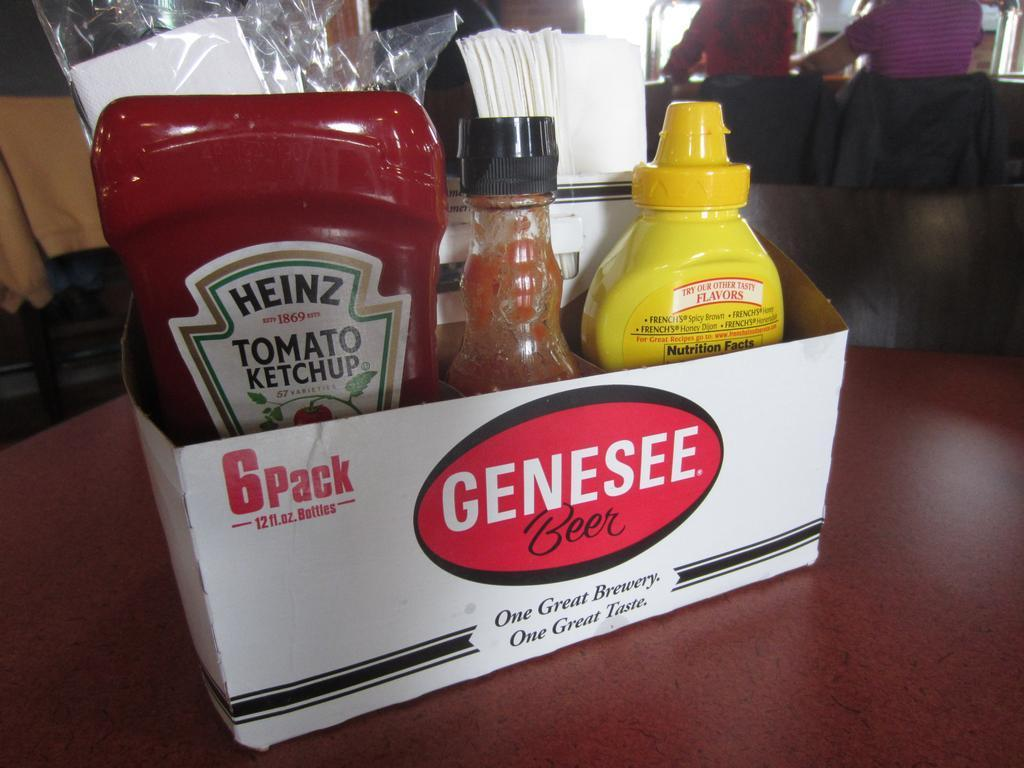What is the main object in the image? There is a box in the image. What is inside the box? The box contains ketchups. What are the flavors of the ketchups? The ketchups have tomato and other nutritious flavors. How much dirt is visible on the ketchups in the image? There is no dirt visible on the ketchups in the image, as the facts provided do not mention any dirt. 